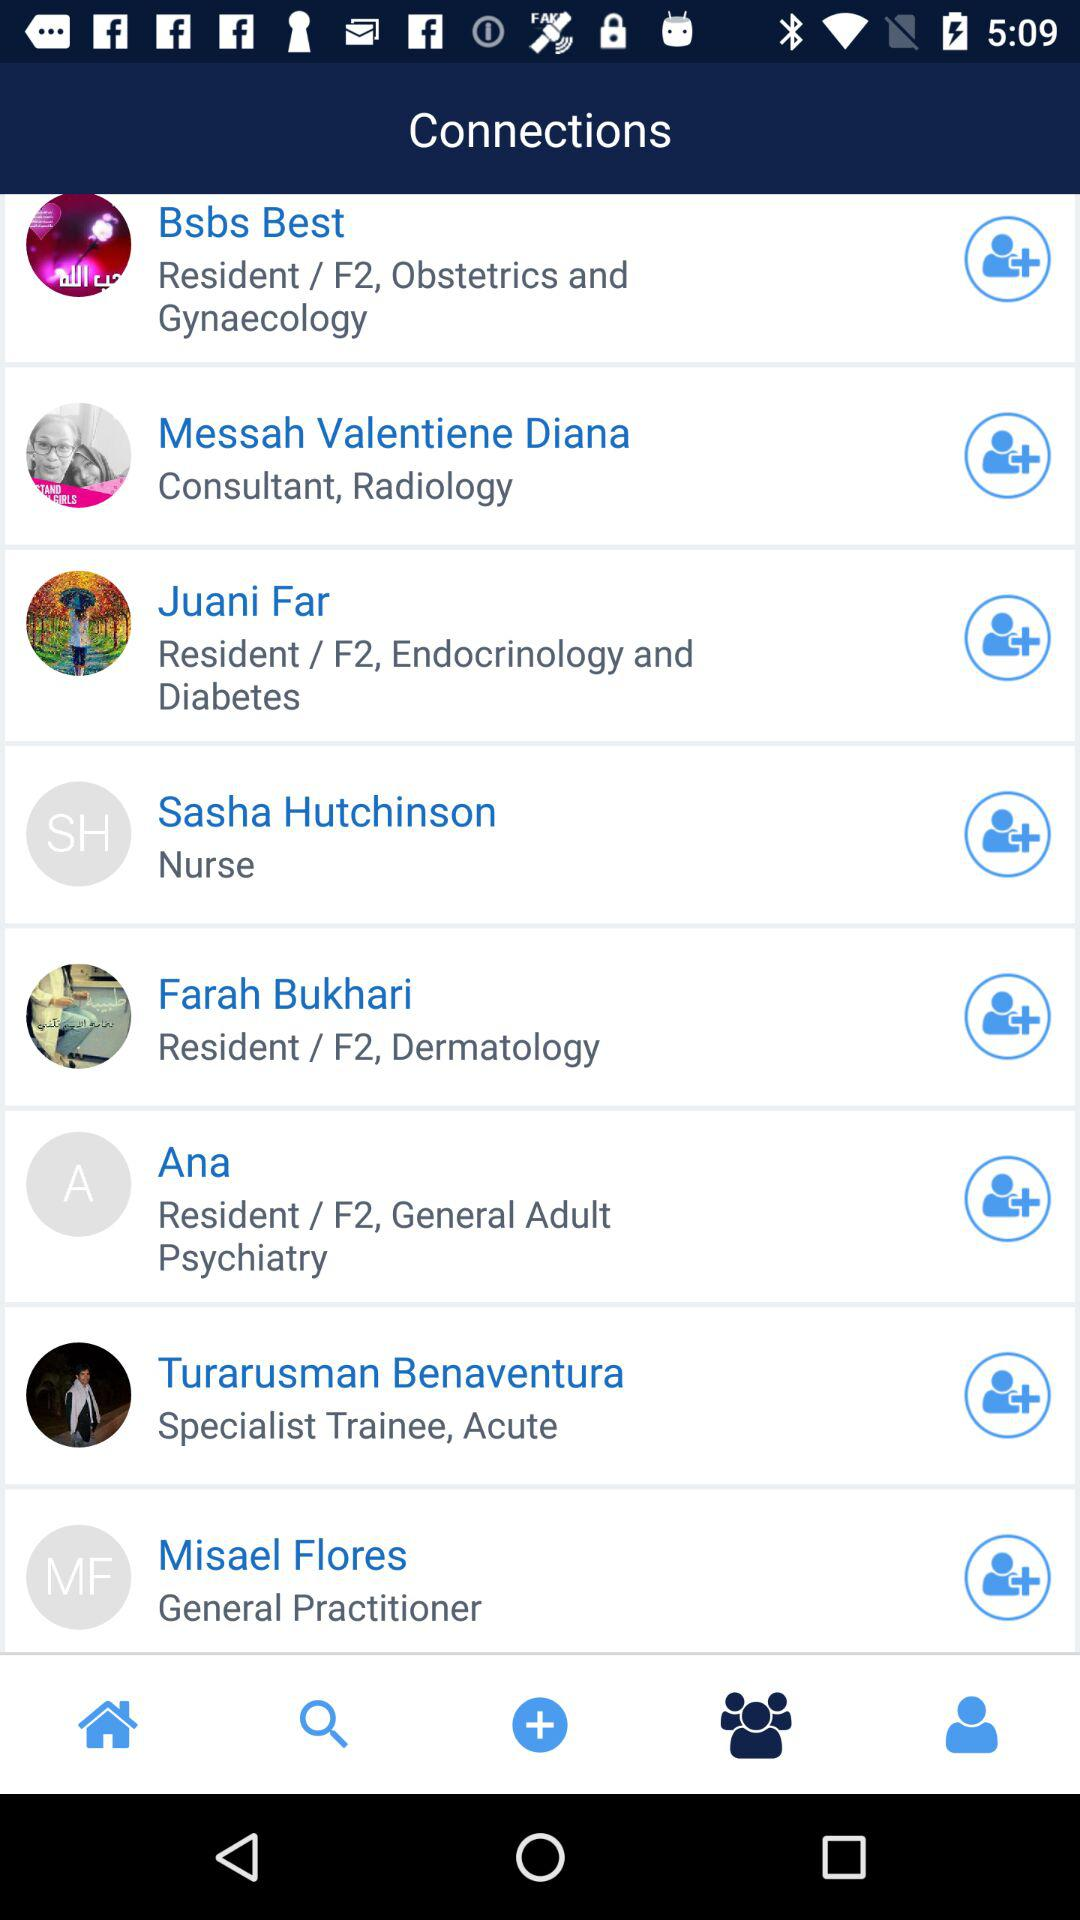What is the specialty of Juani Far? The specialty of Juani Far is endocrinology and diabetes. 